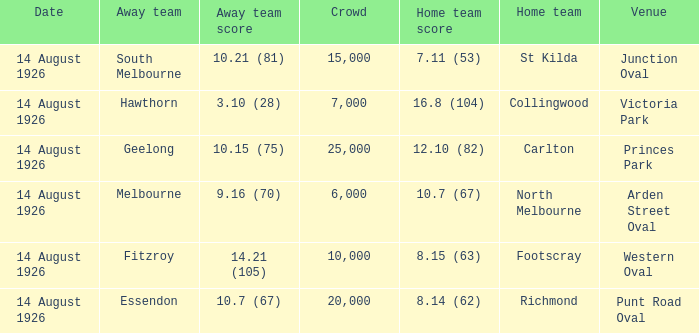What was the smallest crowd that watched an away team score 3.10 (28)? 7000.0. Could you parse the entire table as a dict? {'header': ['Date', 'Away team', 'Away team score', 'Crowd', 'Home team score', 'Home team', 'Venue'], 'rows': [['14 August 1926', 'South Melbourne', '10.21 (81)', '15,000', '7.11 (53)', 'St Kilda', 'Junction Oval'], ['14 August 1926', 'Hawthorn', '3.10 (28)', '7,000', '16.8 (104)', 'Collingwood', 'Victoria Park'], ['14 August 1926', 'Geelong', '10.15 (75)', '25,000', '12.10 (82)', 'Carlton', 'Princes Park'], ['14 August 1926', 'Melbourne', '9.16 (70)', '6,000', '10.7 (67)', 'North Melbourne', 'Arden Street Oval'], ['14 August 1926', 'Fitzroy', '14.21 (105)', '10,000', '8.15 (63)', 'Footscray', 'Western Oval'], ['14 August 1926', 'Essendon', '10.7 (67)', '20,000', '8.14 (62)', 'Richmond', 'Punt Road Oval']]} 